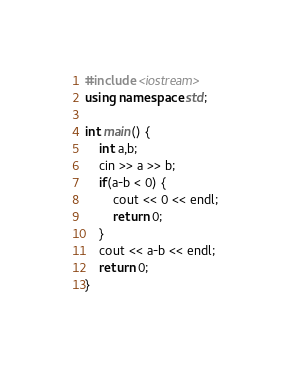<code> <loc_0><loc_0><loc_500><loc_500><_C++_>#include <iostream>
using namespace std;

int main() {
    int a,b;
    cin >> a >> b;
    if(a-b < 0) {
        cout << 0 << endl;
        return 0;
    }
    cout << a-b << endl;
    return 0;
}
</code> 